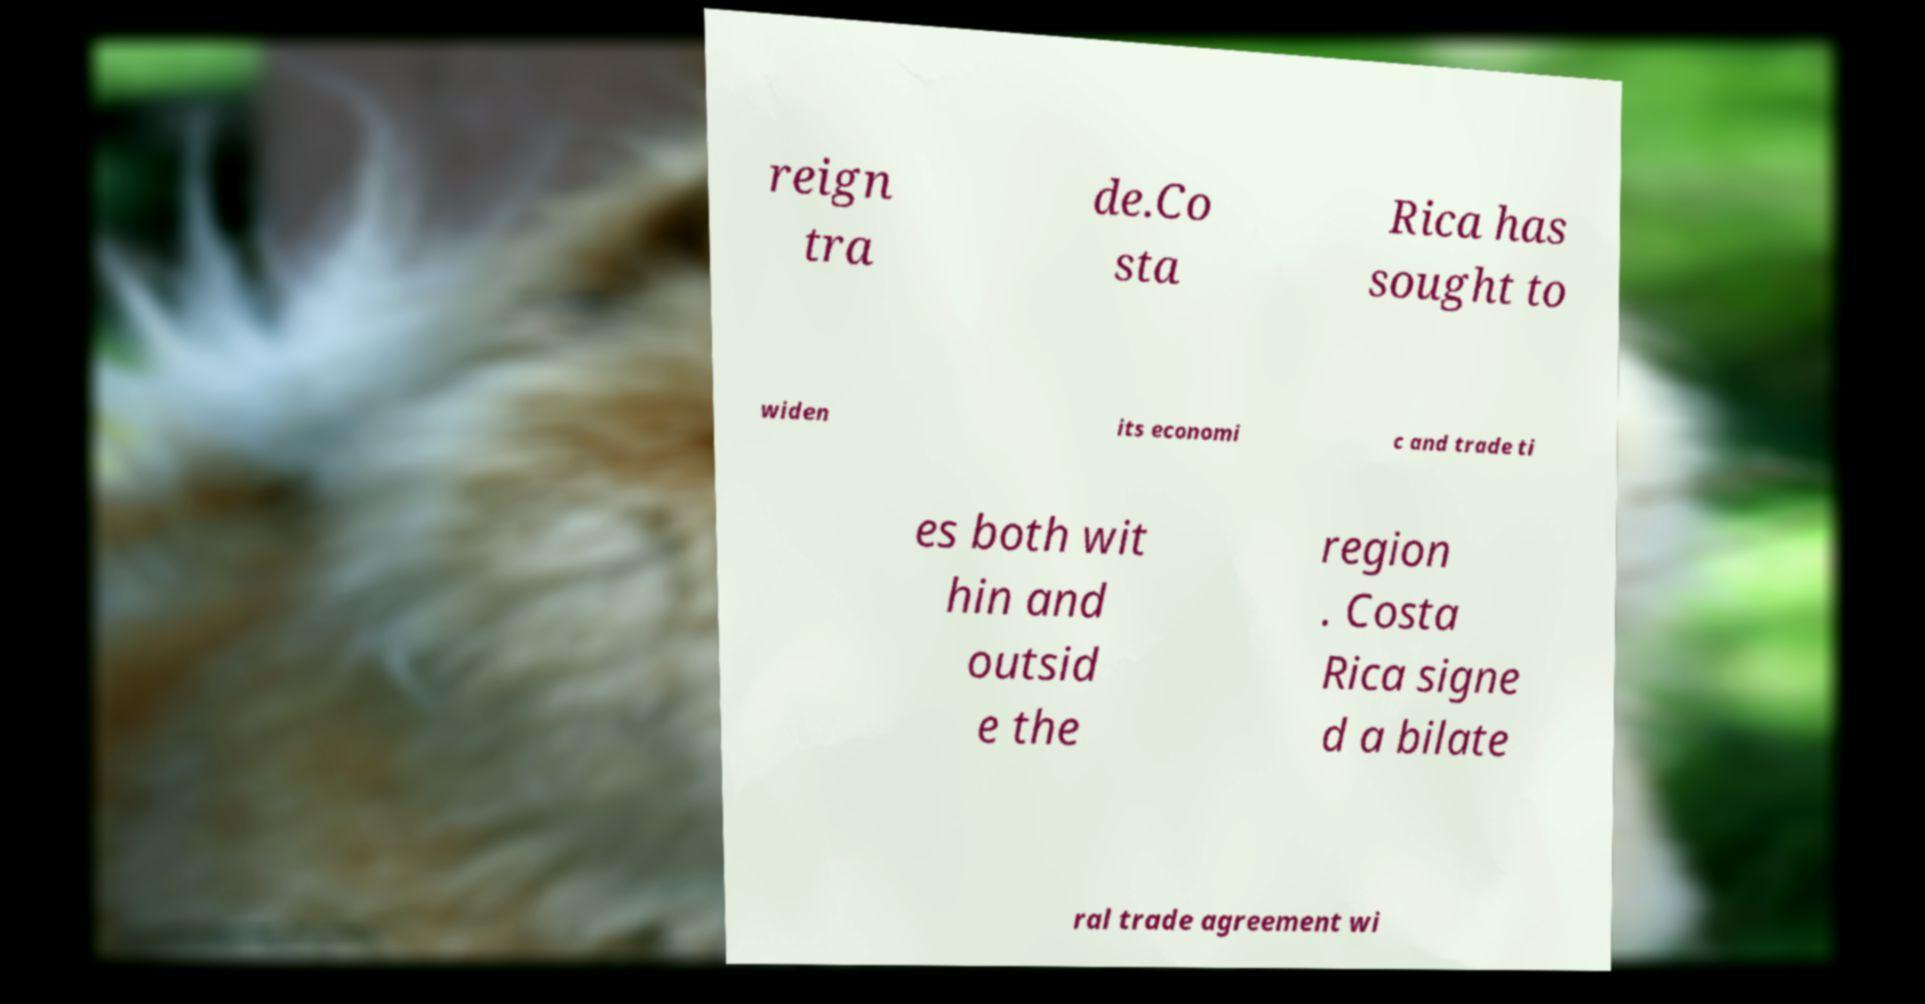There's text embedded in this image that I need extracted. Can you transcribe it verbatim? reign tra de.Co sta Rica has sought to widen its economi c and trade ti es both wit hin and outsid e the region . Costa Rica signe d a bilate ral trade agreement wi 